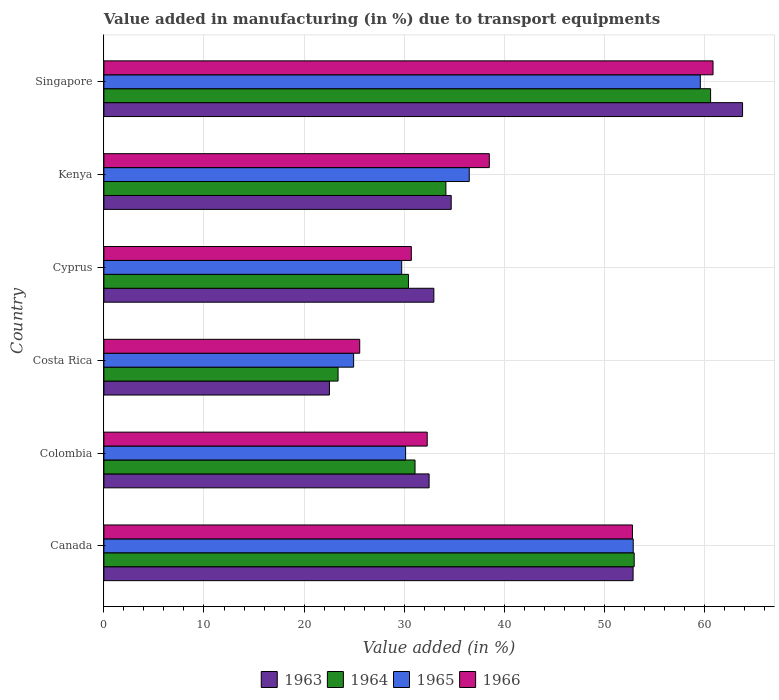Are the number of bars on each tick of the Y-axis equal?
Your answer should be very brief. Yes. How many bars are there on the 1st tick from the bottom?
Provide a succinct answer. 4. What is the label of the 2nd group of bars from the top?
Offer a terse response. Kenya. What is the percentage of value added in manufacturing due to transport equipments in 1963 in Costa Rica?
Your answer should be compact. 22.53. Across all countries, what is the maximum percentage of value added in manufacturing due to transport equipments in 1963?
Offer a terse response. 63.81. Across all countries, what is the minimum percentage of value added in manufacturing due to transport equipments in 1965?
Keep it short and to the point. 24.95. In which country was the percentage of value added in manufacturing due to transport equipments in 1965 maximum?
Offer a very short reply. Singapore. What is the total percentage of value added in manufacturing due to transport equipments in 1963 in the graph?
Provide a succinct answer. 239.38. What is the difference between the percentage of value added in manufacturing due to transport equipments in 1964 in Canada and that in Colombia?
Give a very brief answer. 21.9. What is the difference between the percentage of value added in manufacturing due to transport equipments in 1964 in Costa Rica and the percentage of value added in manufacturing due to transport equipments in 1963 in Singapore?
Provide a short and direct response. -40.41. What is the average percentage of value added in manufacturing due to transport equipments in 1966 per country?
Offer a terse response. 40.13. What is the difference between the percentage of value added in manufacturing due to transport equipments in 1965 and percentage of value added in manufacturing due to transport equipments in 1964 in Kenya?
Ensure brevity in your answer.  2.33. In how many countries, is the percentage of value added in manufacturing due to transport equipments in 1965 greater than 28 %?
Provide a succinct answer. 5. What is the ratio of the percentage of value added in manufacturing due to transport equipments in 1964 in Colombia to that in Singapore?
Your response must be concise. 0.51. Is the difference between the percentage of value added in manufacturing due to transport equipments in 1965 in Colombia and Cyprus greater than the difference between the percentage of value added in manufacturing due to transport equipments in 1964 in Colombia and Cyprus?
Offer a very short reply. No. What is the difference between the highest and the second highest percentage of value added in manufacturing due to transport equipments in 1963?
Offer a very short reply. 10.94. What is the difference between the highest and the lowest percentage of value added in manufacturing due to transport equipments in 1963?
Ensure brevity in your answer.  41.28. In how many countries, is the percentage of value added in manufacturing due to transport equipments in 1964 greater than the average percentage of value added in manufacturing due to transport equipments in 1964 taken over all countries?
Ensure brevity in your answer.  2. Is it the case that in every country, the sum of the percentage of value added in manufacturing due to transport equipments in 1963 and percentage of value added in manufacturing due to transport equipments in 1964 is greater than the sum of percentage of value added in manufacturing due to transport equipments in 1965 and percentage of value added in manufacturing due to transport equipments in 1966?
Give a very brief answer. No. What does the 3rd bar from the top in Canada represents?
Give a very brief answer. 1964. What does the 4th bar from the bottom in Singapore represents?
Your answer should be very brief. 1966. How many bars are there?
Provide a succinct answer. 24. Are all the bars in the graph horizontal?
Make the answer very short. Yes. How many countries are there in the graph?
Make the answer very short. 6. Does the graph contain grids?
Make the answer very short. Yes. How many legend labels are there?
Give a very brief answer. 4. How are the legend labels stacked?
Offer a terse response. Horizontal. What is the title of the graph?
Offer a terse response. Value added in manufacturing (in %) due to transport equipments. Does "1979" appear as one of the legend labels in the graph?
Your response must be concise. No. What is the label or title of the X-axis?
Provide a short and direct response. Value added (in %). What is the Value added (in %) in 1963 in Canada?
Ensure brevity in your answer.  52.87. What is the Value added (in %) of 1964 in Canada?
Offer a very short reply. 52.98. What is the Value added (in %) of 1965 in Canada?
Give a very brief answer. 52.89. What is the Value added (in %) in 1966 in Canada?
Provide a short and direct response. 52.81. What is the Value added (in %) of 1963 in Colombia?
Ensure brevity in your answer.  32.49. What is the Value added (in %) of 1964 in Colombia?
Make the answer very short. 31.09. What is the Value added (in %) in 1965 in Colombia?
Your response must be concise. 30.15. What is the Value added (in %) of 1966 in Colombia?
Your answer should be very brief. 32.3. What is the Value added (in %) of 1963 in Costa Rica?
Give a very brief answer. 22.53. What is the Value added (in %) in 1964 in Costa Rica?
Offer a very short reply. 23.4. What is the Value added (in %) in 1965 in Costa Rica?
Offer a terse response. 24.95. What is the Value added (in %) of 1966 in Costa Rica?
Provide a short and direct response. 25.56. What is the Value added (in %) of 1963 in Cyprus?
Offer a terse response. 32.97. What is the Value added (in %) in 1964 in Cyprus?
Give a very brief answer. 30.43. What is the Value added (in %) in 1965 in Cyprus?
Keep it short and to the point. 29.75. What is the Value added (in %) of 1966 in Cyprus?
Give a very brief answer. 30.72. What is the Value added (in %) of 1963 in Kenya?
Ensure brevity in your answer.  34.7. What is the Value added (in %) in 1964 in Kenya?
Ensure brevity in your answer.  34.17. What is the Value added (in %) of 1965 in Kenya?
Provide a succinct answer. 36.5. What is the Value added (in %) in 1966 in Kenya?
Provide a short and direct response. 38.51. What is the Value added (in %) of 1963 in Singapore?
Your response must be concise. 63.81. What is the Value added (in %) in 1964 in Singapore?
Make the answer very short. 60.62. What is the Value added (in %) of 1965 in Singapore?
Give a very brief answer. 59.59. What is the Value added (in %) of 1966 in Singapore?
Keep it short and to the point. 60.86. Across all countries, what is the maximum Value added (in %) in 1963?
Keep it short and to the point. 63.81. Across all countries, what is the maximum Value added (in %) of 1964?
Provide a short and direct response. 60.62. Across all countries, what is the maximum Value added (in %) of 1965?
Ensure brevity in your answer.  59.59. Across all countries, what is the maximum Value added (in %) of 1966?
Your answer should be compact. 60.86. Across all countries, what is the minimum Value added (in %) of 1963?
Offer a very short reply. 22.53. Across all countries, what is the minimum Value added (in %) in 1964?
Your answer should be compact. 23.4. Across all countries, what is the minimum Value added (in %) in 1965?
Provide a short and direct response. 24.95. Across all countries, what is the minimum Value added (in %) of 1966?
Your response must be concise. 25.56. What is the total Value added (in %) in 1963 in the graph?
Your answer should be very brief. 239.38. What is the total Value added (in %) of 1964 in the graph?
Your response must be concise. 232.68. What is the total Value added (in %) of 1965 in the graph?
Ensure brevity in your answer.  233.83. What is the total Value added (in %) in 1966 in the graph?
Your answer should be compact. 240.76. What is the difference between the Value added (in %) of 1963 in Canada and that in Colombia?
Give a very brief answer. 20.38. What is the difference between the Value added (in %) in 1964 in Canada and that in Colombia?
Ensure brevity in your answer.  21.9. What is the difference between the Value added (in %) of 1965 in Canada and that in Colombia?
Offer a terse response. 22.74. What is the difference between the Value added (in %) in 1966 in Canada and that in Colombia?
Your response must be concise. 20.51. What is the difference between the Value added (in %) in 1963 in Canada and that in Costa Rica?
Your response must be concise. 30.34. What is the difference between the Value added (in %) of 1964 in Canada and that in Costa Rica?
Your response must be concise. 29.59. What is the difference between the Value added (in %) of 1965 in Canada and that in Costa Rica?
Offer a terse response. 27.93. What is the difference between the Value added (in %) of 1966 in Canada and that in Costa Rica?
Keep it short and to the point. 27.25. What is the difference between the Value added (in %) of 1963 in Canada and that in Cyprus?
Your answer should be very brief. 19.91. What is the difference between the Value added (in %) in 1964 in Canada and that in Cyprus?
Give a very brief answer. 22.55. What is the difference between the Value added (in %) in 1965 in Canada and that in Cyprus?
Offer a very short reply. 23.13. What is the difference between the Value added (in %) of 1966 in Canada and that in Cyprus?
Your answer should be very brief. 22.1. What is the difference between the Value added (in %) of 1963 in Canada and that in Kenya?
Make the answer very short. 18.17. What is the difference between the Value added (in %) of 1964 in Canada and that in Kenya?
Provide a succinct answer. 18.81. What is the difference between the Value added (in %) of 1965 in Canada and that in Kenya?
Offer a terse response. 16.38. What is the difference between the Value added (in %) in 1966 in Canada and that in Kenya?
Your answer should be compact. 14.3. What is the difference between the Value added (in %) of 1963 in Canada and that in Singapore?
Offer a terse response. -10.94. What is the difference between the Value added (in %) of 1964 in Canada and that in Singapore?
Make the answer very short. -7.63. What is the difference between the Value added (in %) in 1965 in Canada and that in Singapore?
Your answer should be compact. -6.71. What is the difference between the Value added (in %) in 1966 in Canada and that in Singapore?
Ensure brevity in your answer.  -8.05. What is the difference between the Value added (in %) of 1963 in Colombia and that in Costa Rica?
Your answer should be compact. 9.96. What is the difference between the Value added (in %) in 1964 in Colombia and that in Costa Rica?
Your answer should be very brief. 7.69. What is the difference between the Value added (in %) in 1965 in Colombia and that in Costa Rica?
Your answer should be very brief. 5.2. What is the difference between the Value added (in %) of 1966 in Colombia and that in Costa Rica?
Ensure brevity in your answer.  6.74. What is the difference between the Value added (in %) in 1963 in Colombia and that in Cyprus?
Offer a very short reply. -0.47. What is the difference between the Value added (in %) of 1964 in Colombia and that in Cyprus?
Your response must be concise. 0.66. What is the difference between the Value added (in %) of 1965 in Colombia and that in Cyprus?
Offer a very short reply. 0.39. What is the difference between the Value added (in %) in 1966 in Colombia and that in Cyprus?
Provide a succinct answer. 1.59. What is the difference between the Value added (in %) of 1963 in Colombia and that in Kenya?
Keep it short and to the point. -2.21. What is the difference between the Value added (in %) of 1964 in Colombia and that in Kenya?
Give a very brief answer. -3.08. What is the difference between the Value added (in %) in 1965 in Colombia and that in Kenya?
Provide a short and direct response. -6.36. What is the difference between the Value added (in %) in 1966 in Colombia and that in Kenya?
Your answer should be compact. -6.2. What is the difference between the Value added (in %) of 1963 in Colombia and that in Singapore?
Offer a very short reply. -31.32. What is the difference between the Value added (in %) in 1964 in Colombia and that in Singapore?
Your response must be concise. -29.53. What is the difference between the Value added (in %) in 1965 in Colombia and that in Singapore?
Ensure brevity in your answer.  -29.45. What is the difference between the Value added (in %) in 1966 in Colombia and that in Singapore?
Provide a short and direct response. -28.56. What is the difference between the Value added (in %) of 1963 in Costa Rica and that in Cyprus?
Ensure brevity in your answer.  -10.43. What is the difference between the Value added (in %) in 1964 in Costa Rica and that in Cyprus?
Your answer should be very brief. -7.03. What is the difference between the Value added (in %) in 1965 in Costa Rica and that in Cyprus?
Keep it short and to the point. -4.8. What is the difference between the Value added (in %) in 1966 in Costa Rica and that in Cyprus?
Provide a succinct answer. -5.16. What is the difference between the Value added (in %) in 1963 in Costa Rica and that in Kenya?
Offer a very short reply. -12.17. What is the difference between the Value added (in %) in 1964 in Costa Rica and that in Kenya?
Keep it short and to the point. -10.77. What is the difference between the Value added (in %) of 1965 in Costa Rica and that in Kenya?
Give a very brief answer. -11.55. What is the difference between the Value added (in %) of 1966 in Costa Rica and that in Kenya?
Provide a succinct answer. -12.95. What is the difference between the Value added (in %) of 1963 in Costa Rica and that in Singapore?
Provide a short and direct response. -41.28. What is the difference between the Value added (in %) in 1964 in Costa Rica and that in Singapore?
Provide a succinct answer. -37.22. What is the difference between the Value added (in %) of 1965 in Costa Rica and that in Singapore?
Make the answer very short. -34.64. What is the difference between the Value added (in %) in 1966 in Costa Rica and that in Singapore?
Your response must be concise. -35.3. What is the difference between the Value added (in %) in 1963 in Cyprus and that in Kenya?
Provide a succinct answer. -1.73. What is the difference between the Value added (in %) of 1964 in Cyprus and that in Kenya?
Provide a succinct answer. -3.74. What is the difference between the Value added (in %) in 1965 in Cyprus and that in Kenya?
Keep it short and to the point. -6.75. What is the difference between the Value added (in %) of 1966 in Cyprus and that in Kenya?
Provide a short and direct response. -7.79. What is the difference between the Value added (in %) in 1963 in Cyprus and that in Singapore?
Make the answer very short. -30.84. What is the difference between the Value added (in %) in 1964 in Cyprus and that in Singapore?
Provide a succinct answer. -30.19. What is the difference between the Value added (in %) of 1965 in Cyprus and that in Singapore?
Provide a succinct answer. -29.84. What is the difference between the Value added (in %) in 1966 in Cyprus and that in Singapore?
Your response must be concise. -30.14. What is the difference between the Value added (in %) of 1963 in Kenya and that in Singapore?
Ensure brevity in your answer.  -29.11. What is the difference between the Value added (in %) in 1964 in Kenya and that in Singapore?
Offer a very short reply. -26.45. What is the difference between the Value added (in %) of 1965 in Kenya and that in Singapore?
Your answer should be very brief. -23.09. What is the difference between the Value added (in %) in 1966 in Kenya and that in Singapore?
Offer a terse response. -22.35. What is the difference between the Value added (in %) of 1963 in Canada and the Value added (in %) of 1964 in Colombia?
Your response must be concise. 21.79. What is the difference between the Value added (in %) of 1963 in Canada and the Value added (in %) of 1965 in Colombia?
Your response must be concise. 22.73. What is the difference between the Value added (in %) in 1963 in Canada and the Value added (in %) in 1966 in Colombia?
Keep it short and to the point. 20.57. What is the difference between the Value added (in %) in 1964 in Canada and the Value added (in %) in 1965 in Colombia?
Your answer should be very brief. 22.84. What is the difference between the Value added (in %) in 1964 in Canada and the Value added (in %) in 1966 in Colombia?
Give a very brief answer. 20.68. What is the difference between the Value added (in %) in 1965 in Canada and the Value added (in %) in 1966 in Colombia?
Your answer should be compact. 20.58. What is the difference between the Value added (in %) in 1963 in Canada and the Value added (in %) in 1964 in Costa Rica?
Provide a short and direct response. 29.48. What is the difference between the Value added (in %) of 1963 in Canada and the Value added (in %) of 1965 in Costa Rica?
Provide a short and direct response. 27.92. What is the difference between the Value added (in %) in 1963 in Canada and the Value added (in %) in 1966 in Costa Rica?
Make the answer very short. 27.31. What is the difference between the Value added (in %) in 1964 in Canada and the Value added (in %) in 1965 in Costa Rica?
Give a very brief answer. 28.03. What is the difference between the Value added (in %) in 1964 in Canada and the Value added (in %) in 1966 in Costa Rica?
Give a very brief answer. 27.42. What is the difference between the Value added (in %) in 1965 in Canada and the Value added (in %) in 1966 in Costa Rica?
Keep it short and to the point. 27.33. What is the difference between the Value added (in %) of 1963 in Canada and the Value added (in %) of 1964 in Cyprus?
Keep it short and to the point. 22.44. What is the difference between the Value added (in %) in 1963 in Canada and the Value added (in %) in 1965 in Cyprus?
Offer a very short reply. 23.12. What is the difference between the Value added (in %) in 1963 in Canada and the Value added (in %) in 1966 in Cyprus?
Provide a succinct answer. 22.16. What is the difference between the Value added (in %) in 1964 in Canada and the Value added (in %) in 1965 in Cyprus?
Make the answer very short. 23.23. What is the difference between the Value added (in %) in 1964 in Canada and the Value added (in %) in 1966 in Cyprus?
Keep it short and to the point. 22.27. What is the difference between the Value added (in %) of 1965 in Canada and the Value added (in %) of 1966 in Cyprus?
Offer a terse response. 22.17. What is the difference between the Value added (in %) of 1963 in Canada and the Value added (in %) of 1964 in Kenya?
Your answer should be compact. 18.7. What is the difference between the Value added (in %) in 1963 in Canada and the Value added (in %) in 1965 in Kenya?
Offer a very short reply. 16.37. What is the difference between the Value added (in %) in 1963 in Canada and the Value added (in %) in 1966 in Kenya?
Your answer should be very brief. 14.37. What is the difference between the Value added (in %) of 1964 in Canada and the Value added (in %) of 1965 in Kenya?
Your response must be concise. 16.48. What is the difference between the Value added (in %) of 1964 in Canada and the Value added (in %) of 1966 in Kenya?
Make the answer very short. 14.47. What is the difference between the Value added (in %) of 1965 in Canada and the Value added (in %) of 1966 in Kenya?
Ensure brevity in your answer.  14.38. What is the difference between the Value added (in %) of 1963 in Canada and the Value added (in %) of 1964 in Singapore?
Offer a terse response. -7.74. What is the difference between the Value added (in %) in 1963 in Canada and the Value added (in %) in 1965 in Singapore?
Provide a short and direct response. -6.72. What is the difference between the Value added (in %) in 1963 in Canada and the Value added (in %) in 1966 in Singapore?
Offer a very short reply. -7.99. What is the difference between the Value added (in %) in 1964 in Canada and the Value added (in %) in 1965 in Singapore?
Provide a succinct answer. -6.61. What is the difference between the Value added (in %) of 1964 in Canada and the Value added (in %) of 1966 in Singapore?
Give a very brief answer. -7.88. What is the difference between the Value added (in %) of 1965 in Canada and the Value added (in %) of 1966 in Singapore?
Your answer should be very brief. -7.97. What is the difference between the Value added (in %) in 1963 in Colombia and the Value added (in %) in 1964 in Costa Rica?
Make the answer very short. 9.1. What is the difference between the Value added (in %) in 1963 in Colombia and the Value added (in %) in 1965 in Costa Rica?
Provide a short and direct response. 7.54. What is the difference between the Value added (in %) of 1963 in Colombia and the Value added (in %) of 1966 in Costa Rica?
Offer a very short reply. 6.93. What is the difference between the Value added (in %) of 1964 in Colombia and the Value added (in %) of 1965 in Costa Rica?
Provide a succinct answer. 6.14. What is the difference between the Value added (in %) in 1964 in Colombia and the Value added (in %) in 1966 in Costa Rica?
Ensure brevity in your answer.  5.53. What is the difference between the Value added (in %) of 1965 in Colombia and the Value added (in %) of 1966 in Costa Rica?
Your answer should be compact. 4.59. What is the difference between the Value added (in %) of 1963 in Colombia and the Value added (in %) of 1964 in Cyprus?
Make the answer very short. 2.06. What is the difference between the Value added (in %) of 1963 in Colombia and the Value added (in %) of 1965 in Cyprus?
Offer a terse response. 2.74. What is the difference between the Value added (in %) of 1963 in Colombia and the Value added (in %) of 1966 in Cyprus?
Ensure brevity in your answer.  1.78. What is the difference between the Value added (in %) in 1964 in Colombia and the Value added (in %) in 1965 in Cyprus?
Your response must be concise. 1.33. What is the difference between the Value added (in %) of 1964 in Colombia and the Value added (in %) of 1966 in Cyprus?
Offer a very short reply. 0.37. What is the difference between the Value added (in %) in 1965 in Colombia and the Value added (in %) in 1966 in Cyprus?
Keep it short and to the point. -0.57. What is the difference between the Value added (in %) in 1963 in Colombia and the Value added (in %) in 1964 in Kenya?
Ensure brevity in your answer.  -1.68. What is the difference between the Value added (in %) of 1963 in Colombia and the Value added (in %) of 1965 in Kenya?
Your answer should be very brief. -4.01. What is the difference between the Value added (in %) in 1963 in Colombia and the Value added (in %) in 1966 in Kenya?
Provide a short and direct response. -6.01. What is the difference between the Value added (in %) of 1964 in Colombia and the Value added (in %) of 1965 in Kenya?
Provide a succinct answer. -5.42. What is the difference between the Value added (in %) of 1964 in Colombia and the Value added (in %) of 1966 in Kenya?
Offer a very short reply. -7.42. What is the difference between the Value added (in %) in 1965 in Colombia and the Value added (in %) in 1966 in Kenya?
Offer a very short reply. -8.36. What is the difference between the Value added (in %) of 1963 in Colombia and the Value added (in %) of 1964 in Singapore?
Offer a terse response. -28.12. What is the difference between the Value added (in %) in 1963 in Colombia and the Value added (in %) in 1965 in Singapore?
Provide a succinct answer. -27.1. What is the difference between the Value added (in %) in 1963 in Colombia and the Value added (in %) in 1966 in Singapore?
Your response must be concise. -28.37. What is the difference between the Value added (in %) in 1964 in Colombia and the Value added (in %) in 1965 in Singapore?
Ensure brevity in your answer.  -28.51. What is the difference between the Value added (in %) in 1964 in Colombia and the Value added (in %) in 1966 in Singapore?
Your response must be concise. -29.77. What is the difference between the Value added (in %) in 1965 in Colombia and the Value added (in %) in 1966 in Singapore?
Offer a terse response. -30.71. What is the difference between the Value added (in %) of 1963 in Costa Rica and the Value added (in %) of 1964 in Cyprus?
Keep it short and to the point. -7.9. What is the difference between the Value added (in %) of 1963 in Costa Rica and the Value added (in %) of 1965 in Cyprus?
Make the answer very short. -7.22. What is the difference between the Value added (in %) in 1963 in Costa Rica and the Value added (in %) in 1966 in Cyprus?
Offer a terse response. -8.18. What is the difference between the Value added (in %) in 1964 in Costa Rica and the Value added (in %) in 1965 in Cyprus?
Your answer should be compact. -6.36. What is the difference between the Value added (in %) of 1964 in Costa Rica and the Value added (in %) of 1966 in Cyprus?
Give a very brief answer. -7.32. What is the difference between the Value added (in %) of 1965 in Costa Rica and the Value added (in %) of 1966 in Cyprus?
Give a very brief answer. -5.77. What is the difference between the Value added (in %) in 1963 in Costa Rica and the Value added (in %) in 1964 in Kenya?
Your response must be concise. -11.64. What is the difference between the Value added (in %) of 1963 in Costa Rica and the Value added (in %) of 1965 in Kenya?
Keep it short and to the point. -13.97. What is the difference between the Value added (in %) in 1963 in Costa Rica and the Value added (in %) in 1966 in Kenya?
Provide a succinct answer. -15.97. What is the difference between the Value added (in %) in 1964 in Costa Rica and the Value added (in %) in 1965 in Kenya?
Keep it short and to the point. -13.11. What is the difference between the Value added (in %) in 1964 in Costa Rica and the Value added (in %) in 1966 in Kenya?
Make the answer very short. -15.11. What is the difference between the Value added (in %) of 1965 in Costa Rica and the Value added (in %) of 1966 in Kenya?
Make the answer very short. -13.56. What is the difference between the Value added (in %) in 1963 in Costa Rica and the Value added (in %) in 1964 in Singapore?
Your answer should be compact. -38.08. What is the difference between the Value added (in %) in 1963 in Costa Rica and the Value added (in %) in 1965 in Singapore?
Your answer should be compact. -37.06. What is the difference between the Value added (in %) of 1963 in Costa Rica and the Value added (in %) of 1966 in Singapore?
Provide a short and direct response. -38.33. What is the difference between the Value added (in %) in 1964 in Costa Rica and the Value added (in %) in 1965 in Singapore?
Your answer should be compact. -36.19. What is the difference between the Value added (in %) in 1964 in Costa Rica and the Value added (in %) in 1966 in Singapore?
Your response must be concise. -37.46. What is the difference between the Value added (in %) of 1965 in Costa Rica and the Value added (in %) of 1966 in Singapore?
Offer a terse response. -35.91. What is the difference between the Value added (in %) in 1963 in Cyprus and the Value added (in %) in 1964 in Kenya?
Your answer should be compact. -1.2. What is the difference between the Value added (in %) in 1963 in Cyprus and the Value added (in %) in 1965 in Kenya?
Make the answer very short. -3.54. What is the difference between the Value added (in %) of 1963 in Cyprus and the Value added (in %) of 1966 in Kenya?
Your answer should be compact. -5.54. What is the difference between the Value added (in %) in 1964 in Cyprus and the Value added (in %) in 1965 in Kenya?
Offer a terse response. -6.07. What is the difference between the Value added (in %) of 1964 in Cyprus and the Value added (in %) of 1966 in Kenya?
Your response must be concise. -8.08. What is the difference between the Value added (in %) of 1965 in Cyprus and the Value added (in %) of 1966 in Kenya?
Give a very brief answer. -8.75. What is the difference between the Value added (in %) in 1963 in Cyprus and the Value added (in %) in 1964 in Singapore?
Offer a terse response. -27.65. What is the difference between the Value added (in %) in 1963 in Cyprus and the Value added (in %) in 1965 in Singapore?
Provide a succinct answer. -26.62. What is the difference between the Value added (in %) of 1963 in Cyprus and the Value added (in %) of 1966 in Singapore?
Keep it short and to the point. -27.89. What is the difference between the Value added (in %) of 1964 in Cyprus and the Value added (in %) of 1965 in Singapore?
Offer a terse response. -29.16. What is the difference between the Value added (in %) of 1964 in Cyprus and the Value added (in %) of 1966 in Singapore?
Your answer should be compact. -30.43. What is the difference between the Value added (in %) of 1965 in Cyprus and the Value added (in %) of 1966 in Singapore?
Provide a short and direct response. -31.11. What is the difference between the Value added (in %) of 1963 in Kenya and the Value added (in %) of 1964 in Singapore?
Your answer should be compact. -25.92. What is the difference between the Value added (in %) in 1963 in Kenya and the Value added (in %) in 1965 in Singapore?
Your answer should be very brief. -24.89. What is the difference between the Value added (in %) in 1963 in Kenya and the Value added (in %) in 1966 in Singapore?
Your response must be concise. -26.16. What is the difference between the Value added (in %) of 1964 in Kenya and the Value added (in %) of 1965 in Singapore?
Ensure brevity in your answer.  -25.42. What is the difference between the Value added (in %) in 1964 in Kenya and the Value added (in %) in 1966 in Singapore?
Provide a succinct answer. -26.69. What is the difference between the Value added (in %) in 1965 in Kenya and the Value added (in %) in 1966 in Singapore?
Offer a terse response. -24.36. What is the average Value added (in %) of 1963 per country?
Give a very brief answer. 39.9. What is the average Value added (in %) in 1964 per country?
Your answer should be very brief. 38.78. What is the average Value added (in %) in 1965 per country?
Your answer should be very brief. 38.97. What is the average Value added (in %) in 1966 per country?
Provide a succinct answer. 40.13. What is the difference between the Value added (in %) of 1963 and Value added (in %) of 1964 in Canada?
Keep it short and to the point. -0.11. What is the difference between the Value added (in %) of 1963 and Value added (in %) of 1965 in Canada?
Offer a very short reply. -0.01. What is the difference between the Value added (in %) of 1963 and Value added (in %) of 1966 in Canada?
Give a very brief answer. 0.06. What is the difference between the Value added (in %) of 1964 and Value added (in %) of 1965 in Canada?
Your answer should be compact. 0.1. What is the difference between the Value added (in %) of 1964 and Value added (in %) of 1966 in Canada?
Provide a succinct answer. 0.17. What is the difference between the Value added (in %) in 1965 and Value added (in %) in 1966 in Canada?
Provide a short and direct response. 0.07. What is the difference between the Value added (in %) of 1963 and Value added (in %) of 1964 in Colombia?
Your response must be concise. 1.41. What is the difference between the Value added (in %) of 1963 and Value added (in %) of 1965 in Colombia?
Keep it short and to the point. 2.35. What is the difference between the Value added (in %) of 1963 and Value added (in %) of 1966 in Colombia?
Your answer should be compact. 0.19. What is the difference between the Value added (in %) in 1964 and Value added (in %) in 1965 in Colombia?
Offer a terse response. 0.94. What is the difference between the Value added (in %) in 1964 and Value added (in %) in 1966 in Colombia?
Give a very brief answer. -1.22. What is the difference between the Value added (in %) of 1965 and Value added (in %) of 1966 in Colombia?
Ensure brevity in your answer.  -2.16. What is the difference between the Value added (in %) of 1963 and Value added (in %) of 1964 in Costa Rica?
Provide a short and direct response. -0.86. What is the difference between the Value added (in %) in 1963 and Value added (in %) in 1965 in Costa Rica?
Your answer should be very brief. -2.42. What is the difference between the Value added (in %) of 1963 and Value added (in %) of 1966 in Costa Rica?
Give a very brief answer. -3.03. What is the difference between the Value added (in %) in 1964 and Value added (in %) in 1965 in Costa Rica?
Give a very brief answer. -1.55. What is the difference between the Value added (in %) of 1964 and Value added (in %) of 1966 in Costa Rica?
Make the answer very short. -2.16. What is the difference between the Value added (in %) in 1965 and Value added (in %) in 1966 in Costa Rica?
Ensure brevity in your answer.  -0.61. What is the difference between the Value added (in %) in 1963 and Value added (in %) in 1964 in Cyprus?
Keep it short and to the point. 2.54. What is the difference between the Value added (in %) in 1963 and Value added (in %) in 1965 in Cyprus?
Provide a short and direct response. 3.21. What is the difference between the Value added (in %) of 1963 and Value added (in %) of 1966 in Cyprus?
Provide a succinct answer. 2.25. What is the difference between the Value added (in %) of 1964 and Value added (in %) of 1965 in Cyprus?
Give a very brief answer. 0.68. What is the difference between the Value added (in %) in 1964 and Value added (in %) in 1966 in Cyprus?
Keep it short and to the point. -0.29. What is the difference between the Value added (in %) of 1965 and Value added (in %) of 1966 in Cyprus?
Make the answer very short. -0.96. What is the difference between the Value added (in %) in 1963 and Value added (in %) in 1964 in Kenya?
Your answer should be compact. 0.53. What is the difference between the Value added (in %) of 1963 and Value added (in %) of 1965 in Kenya?
Provide a succinct answer. -1.8. What is the difference between the Value added (in %) in 1963 and Value added (in %) in 1966 in Kenya?
Provide a succinct answer. -3.81. What is the difference between the Value added (in %) in 1964 and Value added (in %) in 1965 in Kenya?
Your answer should be very brief. -2.33. What is the difference between the Value added (in %) of 1964 and Value added (in %) of 1966 in Kenya?
Make the answer very short. -4.34. What is the difference between the Value added (in %) in 1965 and Value added (in %) in 1966 in Kenya?
Keep it short and to the point. -2. What is the difference between the Value added (in %) in 1963 and Value added (in %) in 1964 in Singapore?
Your answer should be compact. 3.19. What is the difference between the Value added (in %) in 1963 and Value added (in %) in 1965 in Singapore?
Provide a succinct answer. 4.22. What is the difference between the Value added (in %) in 1963 and Value added (in %) in 1966 in Singapore?
Your answer should be very brief. 2.95. What is the difference between the Value added (in %) of 1964 and Value added (in %) of 1965 in Singapore?
Ensure brevity in your answer.  1.03. What is the difference between the Value added (in %) in 1964 and Value added (in %) in 1966 in Singapore?
Make the answer very short. -0.24. What is the difference between the Value added (in %) in 1965 and Value added (in %) in 1966 in Singapore?
Provide a short and direct response. -1.27. What is the ratio of the Value added (in %) of 1963 in Canada to that in Colombia?
Offer a very short reply. 1.63. What is the ratio of the Value added (in %) in 1964 in Canada to that in Colombia?
Offer a very short reply. 1.7. What is the ratio of the Value added (in %) of 1965 in Canada to that in Colombia?
Offer a terse response. 1.75. What is the ratio of the Value added (in %) of 1966 in Canada to that in Colombia?
Make the answer very short. 1.63. What is the ratio of the Value added (in %) of 1963 in Canada to that in Costa Rica?
Provide a short and direct response. 2.35. What is the ratio of the Value added (in %) in 1964 in Canada to that in Costa Rica?
Offer a very short reply. 2.26. What is the ratio of the Value added (in %) of 1965 in Canada to that in Costa Rica?
Your answer should be very brief. 2.12. What is the ratio of the Value added (in %) in 1966 in Canada to that in Costa Rica?
Offer a very short reply. 2.07. What is the ratio of the Value added (in %) in 1963 in Canada to that in Cyprus?
Provide a succinct answer. 1.6. What is the ratio of the Value added (in %) in 1964 in Canada to that in Cyprus?
Provide a succinct answer. 1.74. What is the ratio of the Value added (in %) in 1965 in Canada to that in Cyprus?
Your answer should be very brief. 1.78. What is the ratio of the Value added (in %) of 1966 in Canada to that in Cyprus?
Offer a very short reply. 1.72. What is the ratio of the Value added (in %) of 1963 in Canada to that in Kenya?
Your answer should be very brief. 1.52. What is the ratio of the Value added (in %) of 1964 in Canada to that in Kenya?
Keep it short and to the point. 1.55. What is the ratio of the Value added (in %) in 1965 in Canada to that in Kenya?
Your answer should be compact. 1.45. What is the ratio of the Value added (in %) of 1966 in Canada to that in Kenya?
Ensure brevity in your answer.  1.37. What is the ratio of the Value added (in %) in 1963 in Canada to that in Singapore?
Offer a terse response. 0.83. What is the ratio of the Value added (in %) of 1964 in Canada to that in Singapore?
Keep it short and to the point. 0.87. What is the ratio of the Value added (in %) of 1965 in Canada to that in Singapore?
Provide a short and direct response. 0.89. What is the ratio of the Value added (in %) in 1966 in Canada to that in Singapore?
Offer a very short reply. 0.87. What is the ratio of the Value added (in %) of 1963 in Colombia to that in Costa Rica?
Your response must be concise. 1.44. What is the ratio of the Value added (in %) of 1964 in Colombia to that in Costa Rica?
Make the answer very short. 1.33. What is the ratio of the Value added (in %) of 1965 in Colombia to that in Costa Rica?
Offer a very short reply. 1.21. What is the ratio of the Value added (in %) of 1966 in Colombia to that in Costa Rica?
Your answer should be compact. 1.26. What is the ratio of the Value added (in %) in 1963 in Colombia to that in Cyprus?
Your response must be concise. 0.99. What is the ratio of the Value added (in %) in 1964 in Colombia to that in Cyprus?
Offer a very short reply. 1.02. What is the ratio of the Value added (in %) of 1965 in Colombia to that in Cyprus?
Provide a short and direct response. 1.01. What is the ratio of the Value added (in %) of 1966 in Colombia to that in Cyprus?
Offer a terse response. 1.05. What is the ratio of the Value added (in %) in 1963 in Colombia to that in Kenya?
Make the answer very short. 0.94. What is the ratio of the Value added (in %) of 1964 in Colombia to that in Kenya?
Make the answer very short. 0.91. What is the ratio of the Value added (in %) of 1965 in Colombia to that in Kenya?
Offer a very short reply. 0.83. What is the ratio of the Value added (in %) of 1966 in Colombia to that in Kenya?
Provide a succinct answer. 0.84. What is the ratio of the Value added (in %) in 1963 in Colombia to that in Singapore?
Ensure brevity in your answer.  0.51. What is the ratio of the Value added (in %) of 1964 in Colombia to that in Singapore?
Offer a very short reply. 0.51. What is the ratio of the Value added (in %) in 1965 in Colombia to that in Singapore?
Make the answer very short. 0.51. What is the ratio of the Value added (in %) of 1966 in Colombia to that in Singapore?
Offer a terse response. 0.53. What is the ratio of the Value added (in %) of 1963 in Costa Rica to that in Cyprus?
Give a very brief answer. 0.68. What is the ratio of the Value added (in %) in 1964 in Costa Rica to that in Cyprus?
Keep it short and to the point. 0.77. What is the ratio of the Value added (in %) in 1965 in Costa Rica to that in Cyprus?
Your answer should be compact. 0.84. What is the ratio of the Value added (in %) in 1966 in Costa Rica to that in Cyprus?
Ensure brevity in your answer.  0.83. What is the ratio of the Value added (in %) in 1963 in Costa Rica to that in Kenya?
Provide a succinct answer. 0.65. What is the ratio of the Value added (in %) of 1964 in Costa Rica to that in Kenya?
Your response must be concise. 0.68. What is the ratio of the Value added (in %) of 1965 in Costa Rica to that in Kenya?
Make the answer very short. 0.68. What is the ratio of the Value added (in %) of 1966 in Costa Rica to that in Kenya?
Give a very brief answer. 0.66. What is the ratio of the Value added (in %) in 1963 in Costa Rica to that in Singapore?
Your answer should be very brief. 0.35. What is the ratio of the Value added (in %) of 1964 in Costa Rica to that in Singapore?
Offer a terse response. 0.39. What is the ratio of the Value added (in %) of 1965 in Costa Rica to that in Singapore?
Make the answer very short. 0.42. What is the ratio of the Value added (in %) of 1966 in Costa Rica to that in Singapore?
Provide a succinct answer. 0.42. What is the ratio of the Value added (in %) in 1963 in Cyprus to that in Kenya?
Provide a short and direct response. 0.95. What is the ratio of the Value added (in %) in 1964 in Cyprus to that in Kenya?
Provide a succinct answer. 0.89. What is the ratio of the Value added (in %) in 1965 in Cyprus to that in Kenya?
Make the answer very short. 0.82. What is the ratio of the Value added (in %) in 1966 in Cyprus to that in Kenya?
Provide a succinct answer. 0.8. What is the ratio of the Value added (in %) of 1963 in Cyprus to that in Singapore?
Give a very brief answer. 0.52. What is the ratio of the Value added (in %) in 1964 in Cyprus to that in Singapore?
Provide a succinct answer. 0.5. What is the ratio of the Value added (in %) of 1965 in Cyprus to that in Singapore?
Keep it short and to the point. 0.5. What is the ratio of the Value added (in %) of 1966 in Cyprus to that in Singapore?
Make the answer very short. 0.5. What is the ratio of the Value added (in %) of 1963 in Kenya to that in Singapore?
Your response must be concise. 0.54. What is the ratio of the Value added (in %) of 1964 in Kenya to that in Singapore?
Your answer should be compact. 0.56. What is the ratio of the Value added (in %) of 1965 in Kenya to that in Singapore?
Keep it short and to the point. 0.61. What is the ratio of the Value added (in %) of 1966 in Kenya to that in Singapore?
Provide a succinct answer. 0.63. What is the difference between the highest and the second highest Value added (in %) in 1963?
Make the answer very short. 10.94. What is the difference between the highest and the second highest Value added (in %) of 1964?
Your response must be concise. 7.63. What is the difference between the highest and the second highest Value added (in %) in 1965?
Keep it short and to the point. 6.71. What is the difference between the highest and the second highest Value added (in %) of 1966?
Keep it short and to the point. 8.05. What is the difference between the highest and the lowest Value added (in %) of 1963?
Keep it short and to the point. 41.28. What is the difference between the highest and the lowest Value added (in %) of 1964?
Provide a short and direct response. 37.22. What is the difference between the highest and the lowest Value added (in %) in 1965?
Your answer should be very brief. 34.64. What is the difference between the highest and the lowest Value added (in %) in 1966?
Make the answer very short. 35.3. 